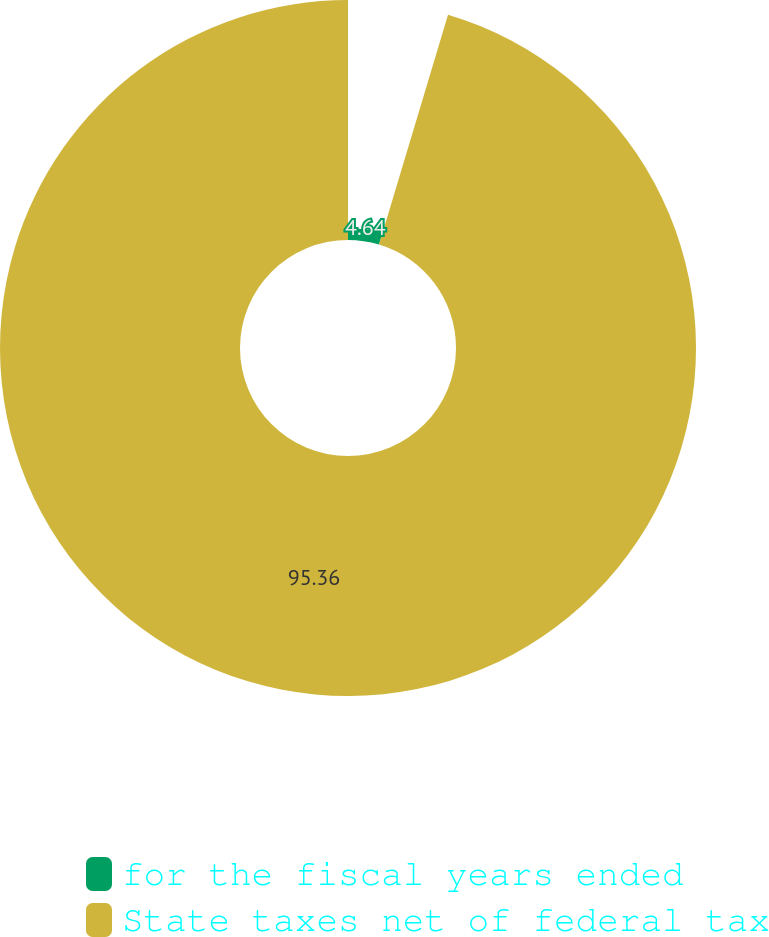<chart> <loc_0><loc_0><loc_500><loc_500><pie_chart><fcel>for the fiscal years ended<fcel>State taxes net of federal tax<nl><fcel>4.64%<fcel>95.36%<nl></chart> 